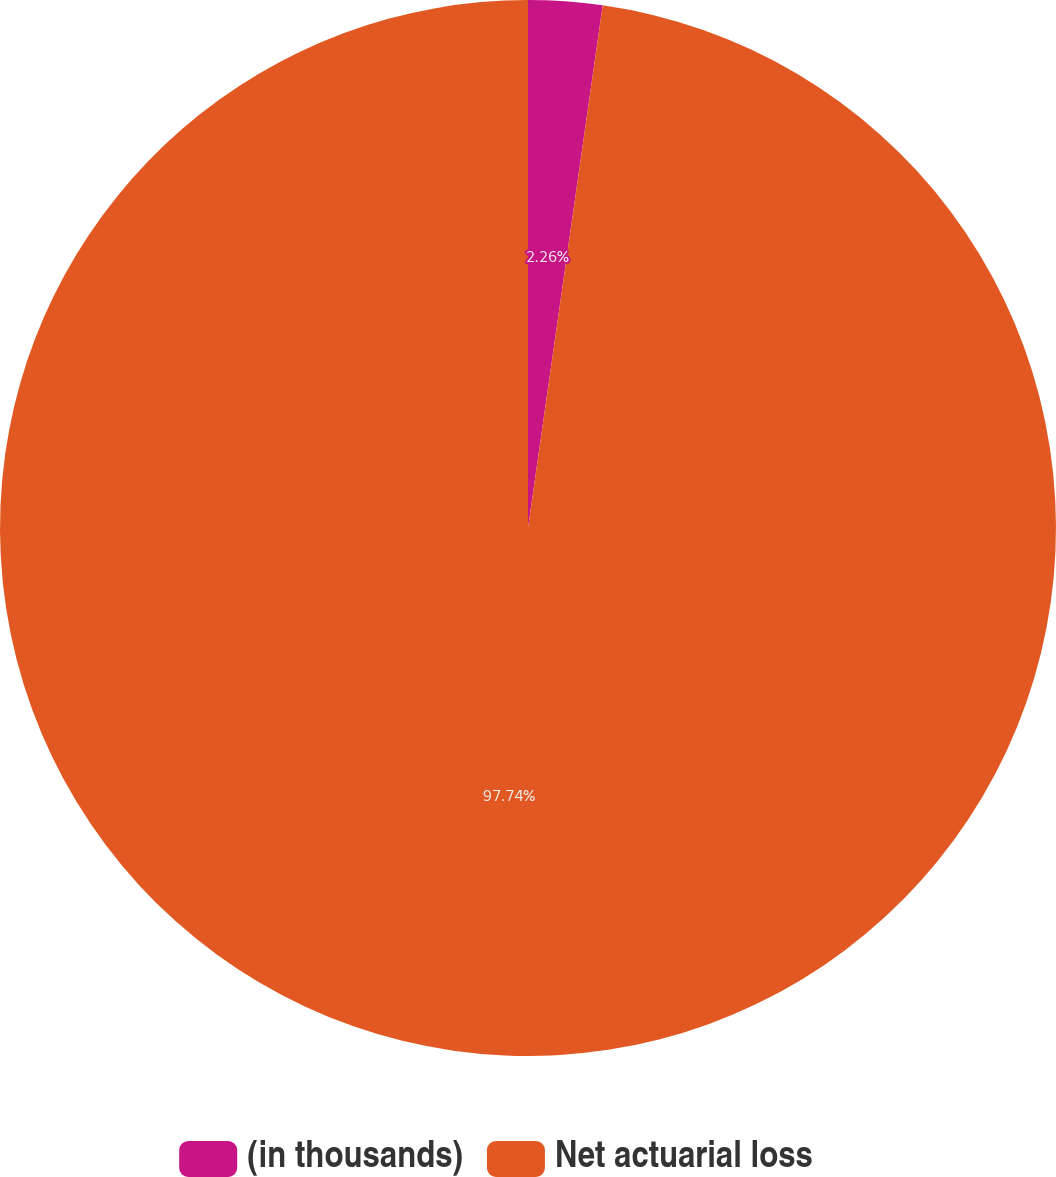Convert chart to OTSL. <chart><loc_0><loc_0><loc_500><loc_500><pie_chart><fcel>(in thousands)<fcel>Net actuarial loss<nl><fcel>2.26%<fcel>97.74%<nl></chart> 